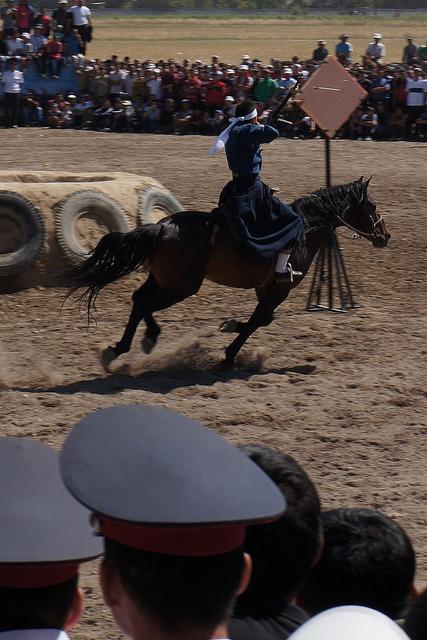What is on the man's face?
Short answer required. Blindfold. Is the horse lying down?
Write a very short answer. No. Is the man riding a horse?
Short answer required. Yes. 